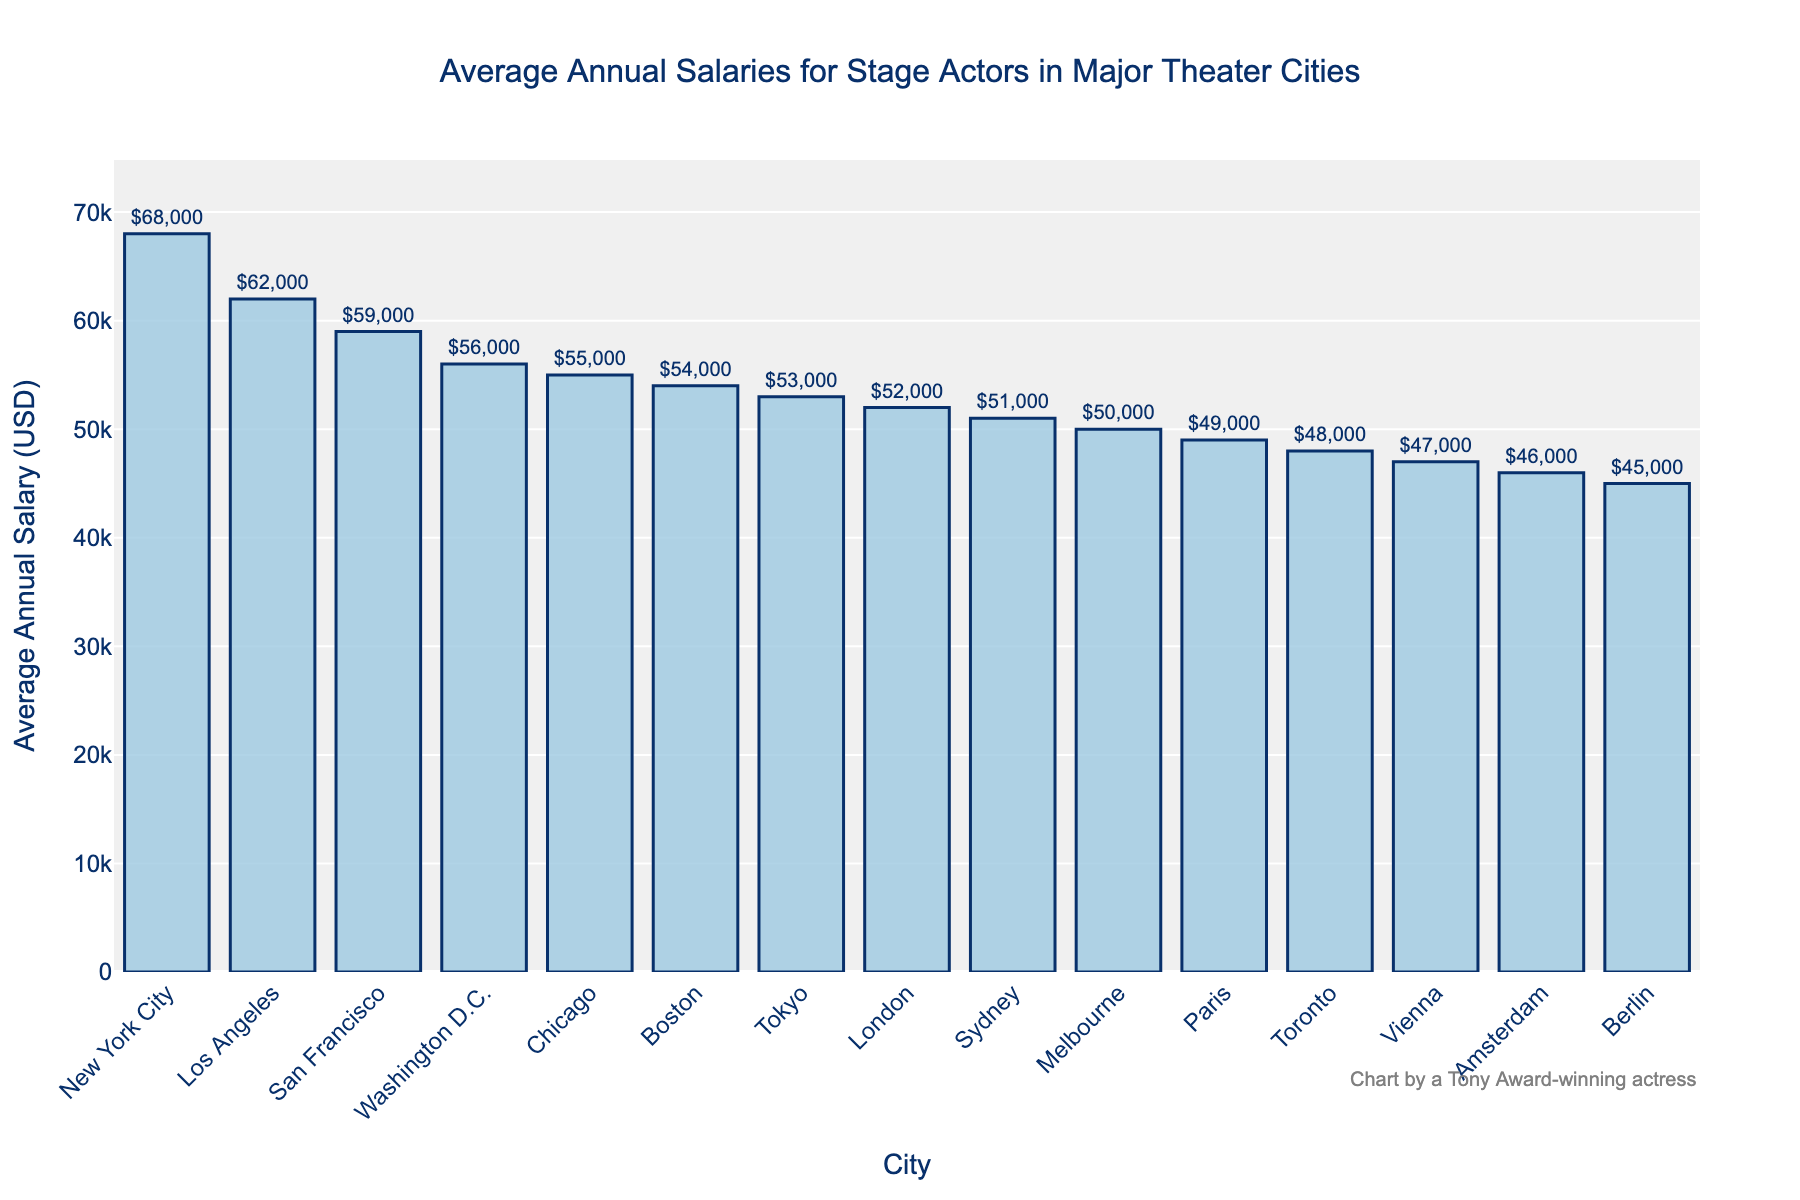Which city has the highest average annual salary for stage actors? The bar chart indicates the height of each bar representing the average annual salary. The tallest bar corresponds to New York City, indicating it has the highest average annual salary.
Answer: New York City What is the difference in average annual salaries between New York City and Berlin? To find the difference, subtract Berlin's average annual salary from New York City's. From the chart, New York City's salary is $68,000 and Berlin's is $45,000. So, $68,000 - $45,000 = $23,000.
Answer: $23,000 Which city has a higher average annual salary for stage actors: Los Angeles or Chicago? Compare the heights of the bars for Los Angeles and Chicago. The bar for Los Angeles is higher than the bar for Chicago. Thus, Los Angeles has a higher salary.
Answer: Los Angeles What is the average annual salary for stage actors in cities with less than $50,000? Identify the cities with average salaries less than $50,000 (Toronto, Sydney, Berlin, Paris, Vienna, Amsterdam). Average these values: (48000 + 51000 + 45000 + 49000 + 47000 + 46000) / 6 = 48000.
Answer: $48,000 How does Washington D.C.'s average salary compare to San Francisco's? Compare the heights of the bars for Washington D.C. and San Francisco. The bar for San Francisco is slightly higher than Washington D.C.
Answer: San Francisco is higher Which city is closest to the average annual salary of $54,000? Identify the bar heights close to $54,000. Boston has an average salary of $54,000, which closely matches the given value.
Answer: Boston What's the average of the highest (New York City) and lowest (Berlin) salaries? Add the highest and lowest salaries: $68,000 (New York City) + $45,000 (Berlin) and divide by 2. ($68,000 + $45,000) / 2 = $56,500.
Answer: $56,500 Rank the cities from highest to lowest average annual salary. List the cities based on the bar heights from the highest to the lowest: 
1. New York City
2. Los Angeles
3. San Francisco
4. Washington D.C.
5. Chicago
6. Boston
7. London
8. Tokyo
9. Melbourne
10. Sydney
11. Toronto
12. Paris
13. Vienna
14. Amsterdam
15. Berlin
Answer: New York City, Los Angeles, San Francisco, Washington D.C., Chicago, Boston, London, Tokyo, Melbourne, Sydney, Toronto, Paris, Vienna, Amsterdam, Berlin What is the total average annual salary for stage actors in London and Tokyo? Add the average annual salaries for London and Tokyo: $52,000 + $53,000 = $105,000.
Answer: $105,000 